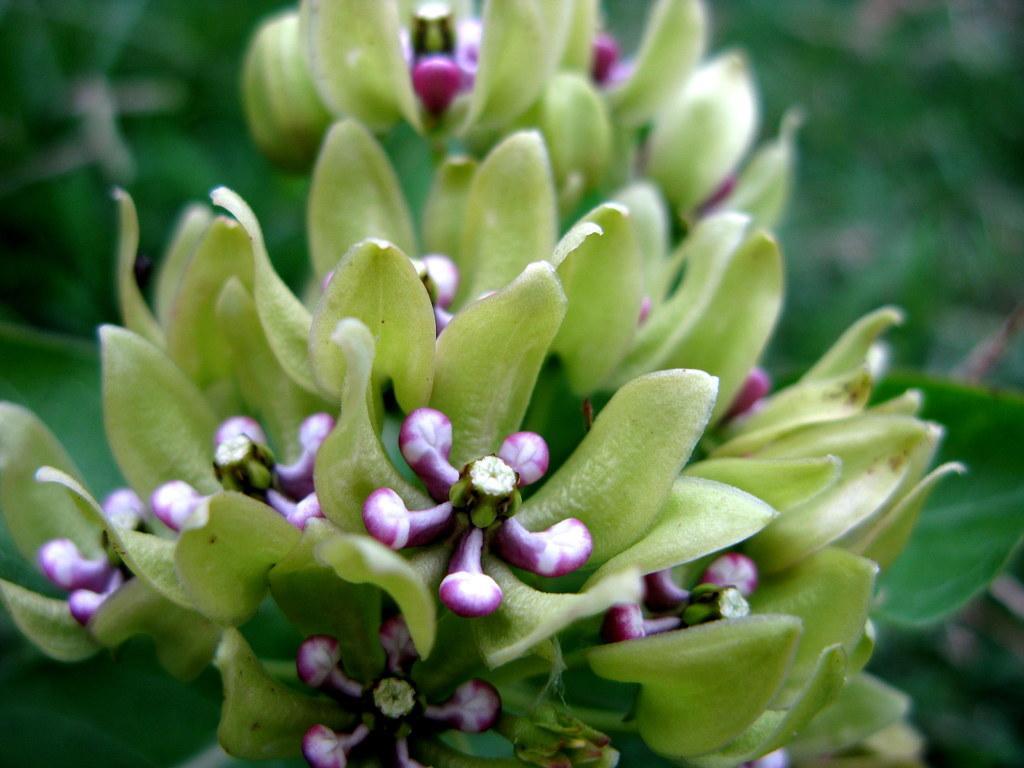Describe this image in one or two sentences. In this image I can see few flowers in white and purple color and I can see few leaves in green color. 